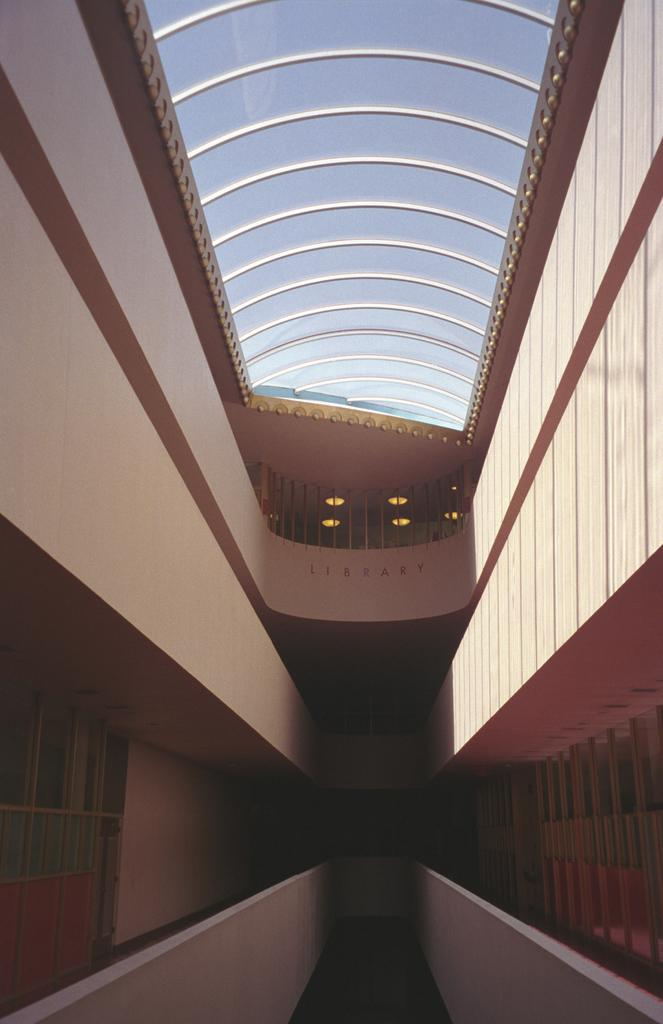What part of a building is shown in the image? The image shows the inner part of a building. What architectural feature can be seen in the image? There are windows visible in the image. What safety feature is present at the top of the image? There is a railing at the top of the image. What part of the building is visible at the top of the image? The roof is visible in the image. Can you see people swimming in the image? There is no swimming pool or people swimming present in the image. What type of headwear is worn by the person in the image? There is no person or headwear visible in the image. 